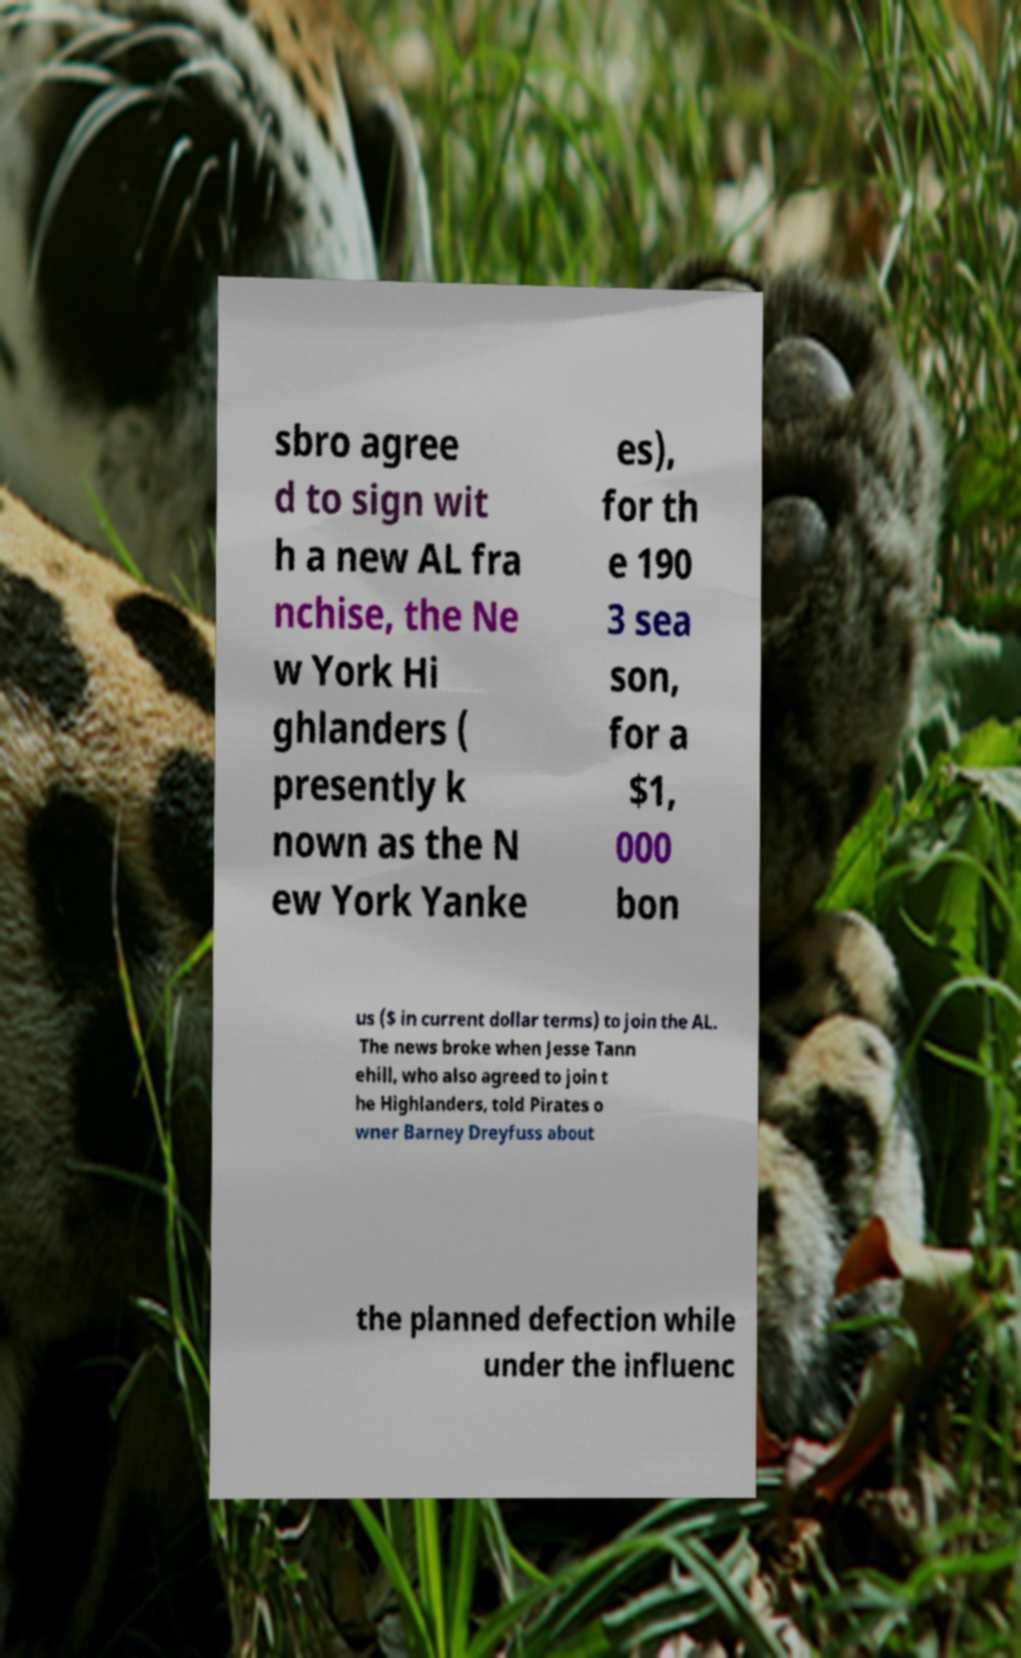Could you extract and type out the text from this image? sbro agree d to sign wit h a new AL fra nchise, the Ne w York Hi ghlanders ( presently k nown as the N ew York Yanke es), for th e 190 3 sea son, for a $1, 000 bon us ($ in current dollar terms) to join the AL. The news broke when Jesse Tann ehill, who also agreed to join t he Highlanders, told Pirates o wner Barney Dreyfuss about the planned defection while under the influenc 